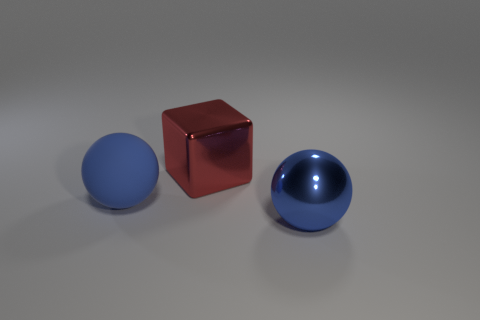Add 1 large gray matte spheres. How many objects exist? 4 Subtract all balls. How many objects are left? 1 Subtract all large blue metallic balls. Subtract all big blue rubber spheres. How many objects are left? 1 Add 2 big matte things. How many big matte things are left? 3 Add 1 large shiny blocks. How many large shiny blocks exist? 2 Subtract 0 green blocks. How many objects are left? 3 